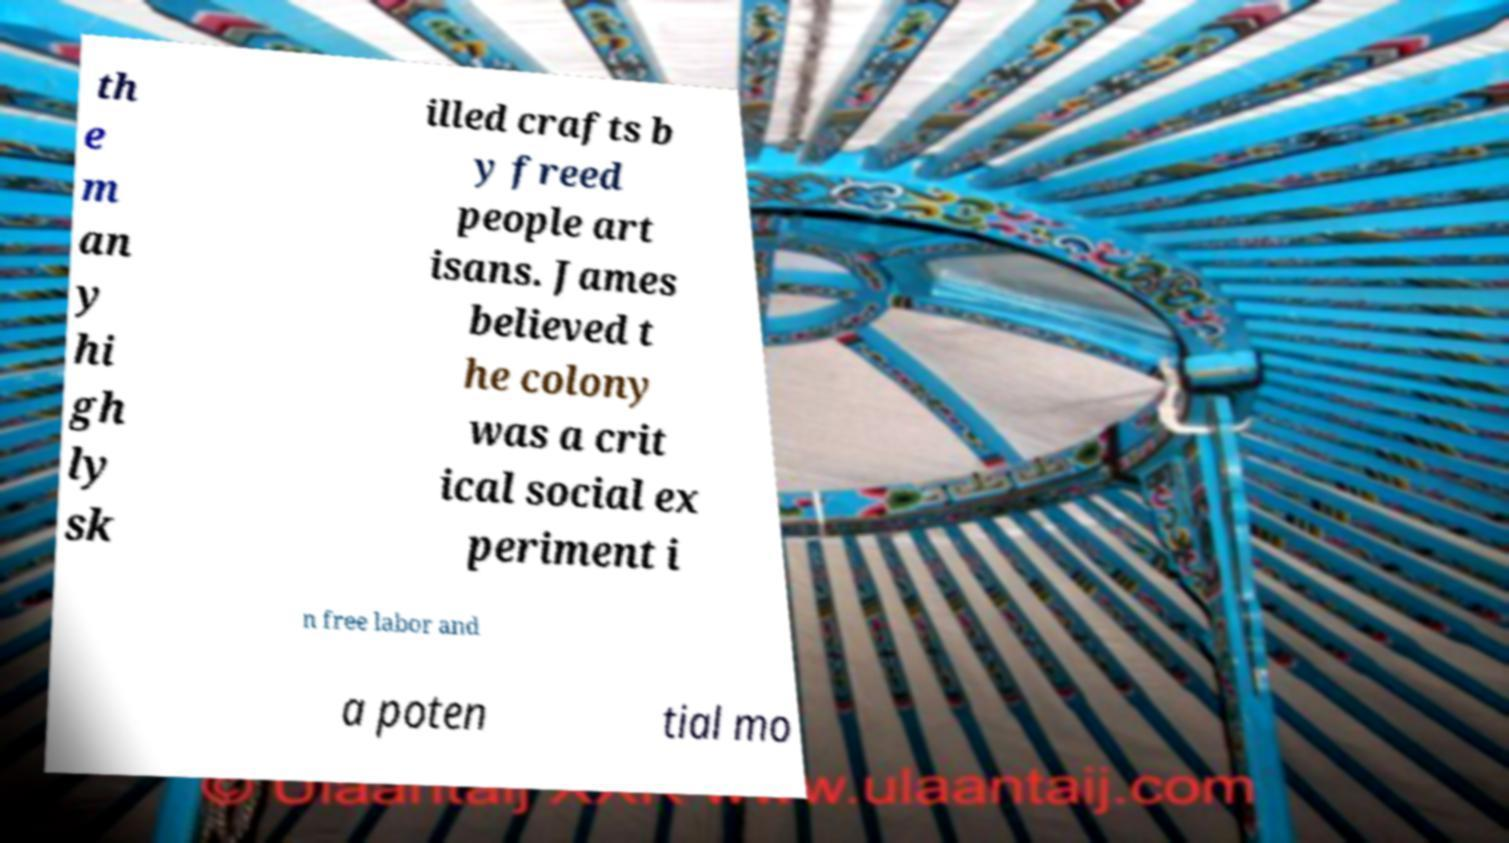What messages or text are displayed in this image? I need them in a readable, typed format. th e m an y hi gh ly sk illed crafts b y freed people art isans. James believed t he colony was a crit ical social ex periment i n free labor and a poten tial mo 